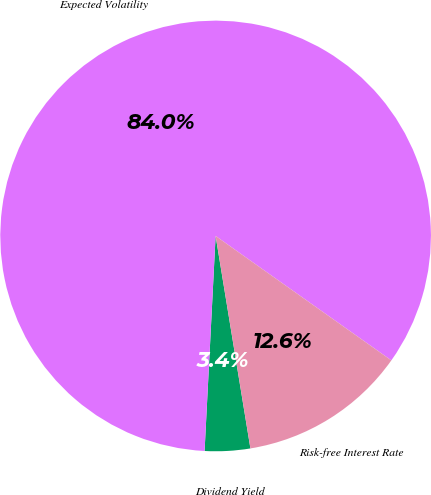Convert chart. <chart><loc_0><loc_0><loc_500><loc_500><pie_chart><fcel>Dividend Yield<fcel>Expected Volatility<fcel>Risk-free Interest Rate<nl><fcel>3.4%<fcel>83.99%<fcel>12.61%<nl></chart> 